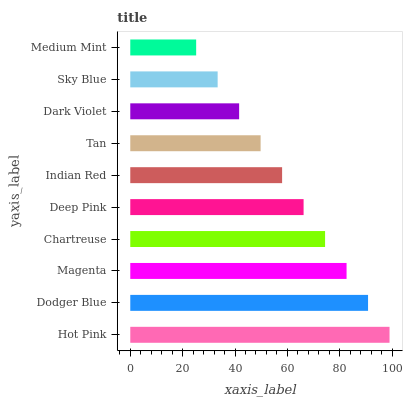Is Medium Mint the minimum?
Answer yes or no. Yes. Is Hot Pink the maximum?
Answer yes or no. Yes. Is Dodger Blue the minimum?
Answer yes or no. No. Is Dodger Blue the maximum?
Answer yes or no. No. Is Hot Pink greater than Dodger Blue?
Answer yes or no. Yes. Is Dodger Blue less than Hot Pink?
Answer yes or no. Yes. Is Dodger Blue greater than Hot Pink?
Answer yes or no. No. Is Hot Pink less than Dodger Blue?
Answer yes or no. No. Is Deep Pink the high median?
Answer yes or no. Yes. Is Indian Red the low median?
Answer yes or no. Yes. Is Dark Violet the high median?
Answer yes or no. No. Is Magenta the low median?
Answer yes or no. No. 